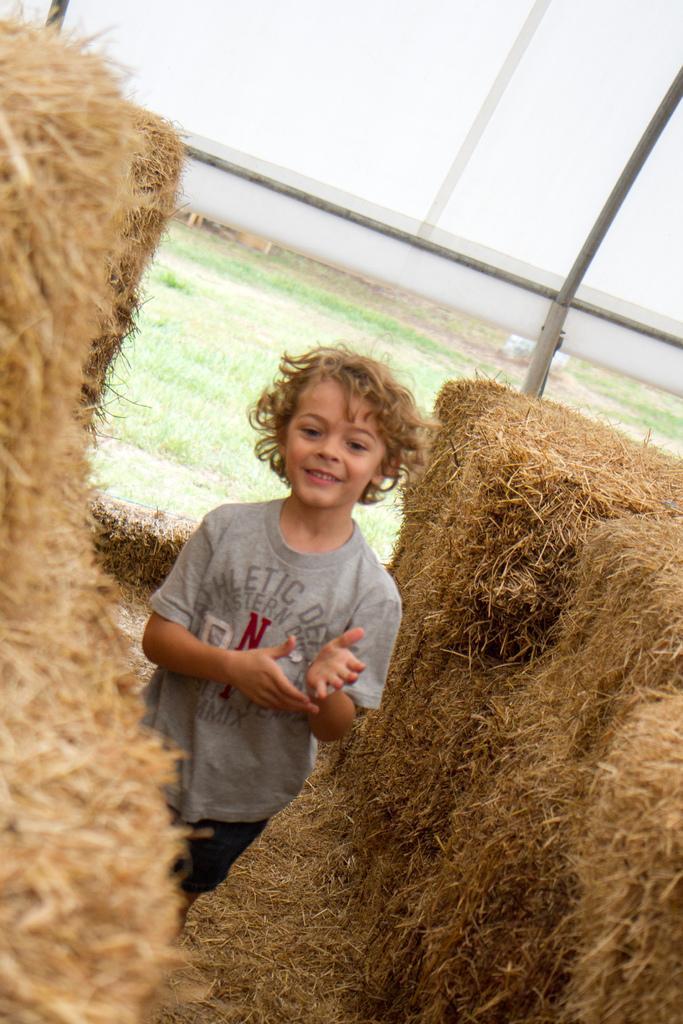How would you summarize this image in a sentence or two? In this picture we can see a kid is standing and smiling, on the right side and left side we can see hay, in the background there is grass, it looks like a banner in the background. 